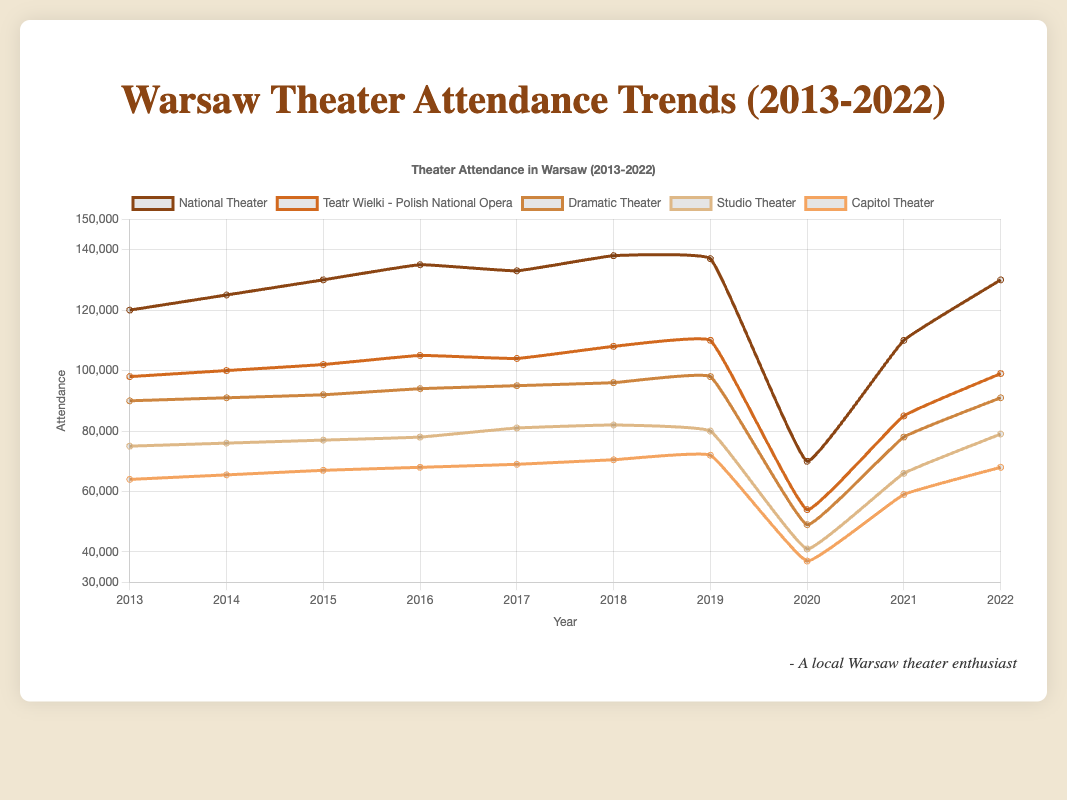What was the attendance at the National Theater in 2020 and how did it recover in 2021? The attendance at the National Theater was 70,000 in 2020. In 2021, it recovered to 110,000. This shows a recovery of 40,000 attendees.
Answer: 70,000 in 2020, recovered by 40,000 in 2021 Which theater had the least attendance in 2020? In 2020, the Studio Theater had the least attendance with 41,000 attendees.
Answer: Studio Theater with 41,000 What is the overall trend in attendance for the Capitol Theater from 2013 to 2022? The Capitol Theater saw a generally increasing trend from 2013 (64,000) to 2019 (72,000), a significant drop in 2020 (37,000), and then partial recovery to 68,000 in 2022.
Answer: Increasing until 2019, drop in 2020, partial recovery in 2022 Which year had the highest average attendance across all theaters? Calculating the average attendance for each year and finding the maximum, the year 2018 had the highest average attendance.
Answer: 2018 How did the Studio Theater's attendance in 2017 compare to its attendance in 2021? In 2017, the Studio Theater had 81,000 attendees. In 2021, it had 66,000. This shows a decrease of 15,000 attendees.
Answer: 81,000 in 2017, 66,000 in 2021 What was the total attendance for the National Theater from 2013-2022? Sum the attendance numbers for the National Theater from 2013 to 2022: 120,000 + 125,000 + 130,000 + 135,000 + 133,000 + 138,000 + 137,000 + 70,000 + 110,000 + 130,000 = 1,228,000.
Answer: 1,228,000 Between the Dramatic Theater and Capitol Theater, which had a more stable attendance trend from 2013 to 2019? By observing the lines, Dramatic Theater shows a more stable trend with minor increases each year, whereas Capitol Theater shows a similar but slightly more variable trend.
Answer: Dramatic Theater What was the average attendance for the Teatr Wielki - Polish National Opera in the years 2013, 2015, and 2017? Calculate the average attendance for those years: (98,000 (2013) + 102,000 (2015) + 104,000 (2017))/3 = 101,333.
Answer: 101,333 Which theater had the highest attendance decline from 2019 to 2020? The National Theater had the highest decline, dropping from 137,000 in 2019 to 70,000 in 2020, a total decline of 67,000.
Answer: National Theater 